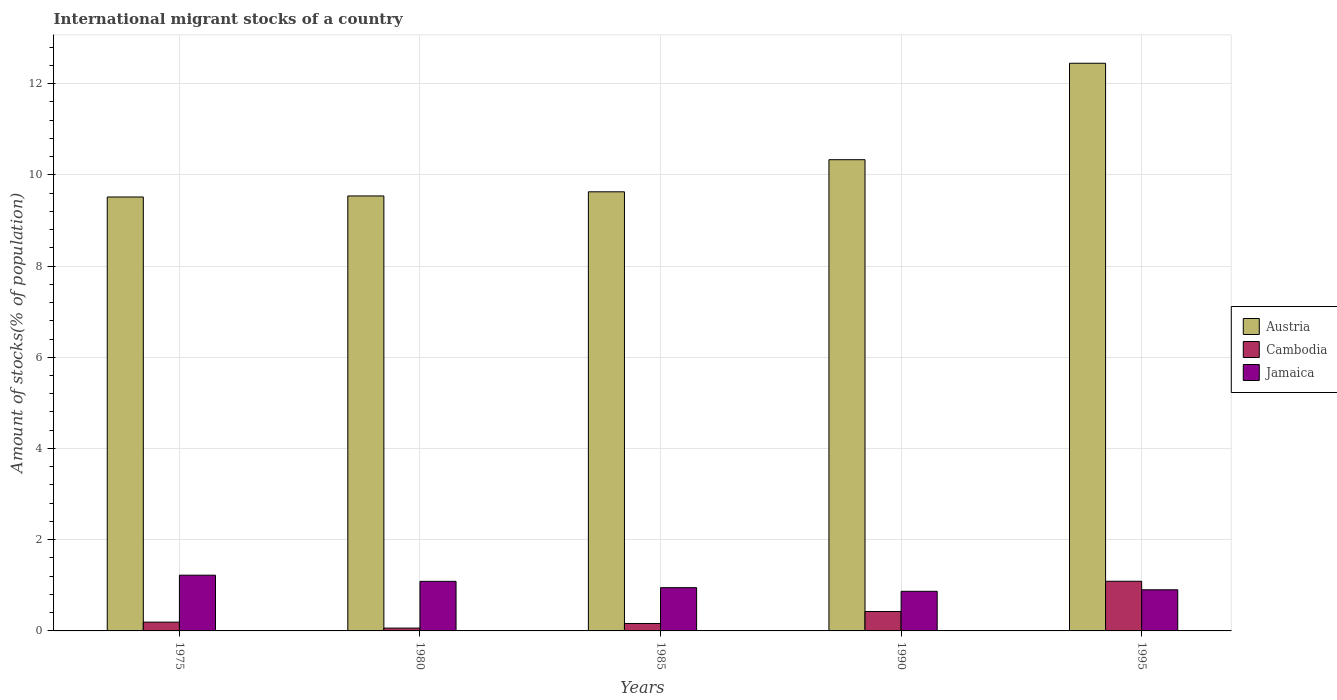What is the label of the 3rd group of bars from the left?
Offer a terse response. 1985. What is the amount of stocks in in Austria in 1985?
Give a very brief answer. 9.63. Across all years, what is the maximum amount of stocks in in Jamaica?
Make the answer very short. 1.22. Across all years, what is the minimum amount of stocks in in Austria?
Make the answer very short. 9.51. What is the total amount of stocks in in Jamaica in the graph?
Offer a terse response. 5.03. What is the difference between the amount of stocks in in Austria in 1975 and that in 1980?
Offer a very short reply. -0.02. What is the difference between the amount of stocks in in Austria in 1995 and the amount of stocks in in Jamaica in 1980?
Ensure brevity in your answer.  11.36. What is the average amount of stocks in in Austria per year?
Give a very brief answer. 10.29. In the year 1975, what is the difference between the amount of stocks in in Austria and amount of stocks in in Jamaica?
Your answer should be very brief. 8.29. In how many years, is the amount of stocks in in Austria greater than 1.6 %?
Offer a very short reply. 5. What is the ratio of the amount of stocks in in Jamaica in 1985 to that in 1990?
Your answer should be compact. 1.09. Is the amount of stocks in in Austria in 1985 less than that in 1990?
Offer a terse response. Yes. What is the difference between the highest and the second highest amount of stocks in in Jamaica?
Provide a succinct answer. 0.14. What is the difference between the highest and the lowest amount of stocks in in Cambodia?
Give a very brief answer. 1.03. In how many years, is the amount of stocks in in Jamaica greater than the average amount of stocks in in Jamaica taken over all years?
Your response must be concise. 2. What does the 2nd bar from the right in 1980 represents?
Your answer should be very brief. Cambodia. Is it the case that in every year, the sum of the amount of stocks in in Cambodia and amount of stocks in in Jamaica is greater than the amount of stocks in in Austria?
Keep it short and to the point. No. How many bars are there?
Offer a very short reply. 15. What is the difference between two consecutive major ticks on the Y-axis?
Ensure brevity in your answer.  2. How many legend labels are there?
Ensure brevity in your answer.  3. How are the legend labels stacked?
Make the answer very short. Vertical. What is the title of the graph?
Your answer should be very brief. International migrant stocks of a country. Does "Belarus" appear as one of the legend labels in the graph?
Make the answer very short. No. What is the label or title of the Y-axis?
Your answer should be compact. Amount of stocks(% of population). What is the Amount of stocks(% of population) in Austria in 1975?
Your response must be concise. 9.51. What is the Amount of stocks(% of population) of Cambodia in 1975?
Give a very brief answer. 0.19. What is the Amount of stocks(% of population) of Jamaica in 1975?
Provide a succinct answer. 1.22. What is the Amount of stocks(% of population) of Austria in 1980?
Your response must be concise. 9.54. What is the Amount of stocks(% of population) of Cambodia in 1980?
Ensure brevity in your answer.  0.06. What is the Amount of stocks(% of population) in Jamaica in 1980?
Offer a very short reply. 1.09. What is the Amount of stocks(% of population) in Austria in 1985?
Your response must be concise. 9.63. What is the Amount of stocks(% of population) of Cambodia in 1985?
Offer a terse response. 0.16. What is the Amount of stocks(% of population) of Jamaica in 1985?
Provide a short and direct response. 0.95. What is the Amount of stocks(% of population) of Austria in 1990?
Provide a succinct answer. 10.33. What is the Amount of stocks(% of population) of Cambodia in 1990?
Offer a very short reply. 0.43. What is the Amount of stocks(% of population) of Jamaica in 1990?
Make the answer very short. 0.87. What is the Amount of stocks(% of population) of Austria in 1995?
Keep it short and to the point. 12.45. What is the Amount of stocks(% of population) of Cambodia in 1995?
Provide a succinct answer. 1.09. What is the Amount of stocks(% of population) in Jamaica in 1995?
Provide a succinct answer. 0.9. Across all years, what is the maximum Amount of stocks(% of population) of Austria?
Provide a short and direct response. 12.45. Across all years, what is the maximum Amount of stocks(% of population) in Cambodia?
Keep it short and to the point. 1.09. Across all years, what is the maximum Amount of stocks(% of population) in Jamaica?
Make the answer very short. 1.22. Across all years, what is the minimum Amount of stocks(% of population) of Austria?
Your answer should be compact. 9.51. Across all years, what is the minimum Amount of stocks(% of population) of Cambodia?
Your answer should be very brief. 0.06. Across all years, what is the minimum Amount of stocks(% of population) in Jamaica?
Your answer should be compact. 0.87. What is the total Amount of stocks(% of population) of Austria in the graph?
Offer a terse response. 51.46. What is the total Amount of stocks(% of population) of Cambodia in the graph?
Your response must be concise. 1.93. What is the total Amount of stocks(% of population) of Jamaica in the graph?
Offer a terse response. 5.03. What is the difference between the Amount of stocks(% of population) of Austria in 1975 and that in 1980?
Your answer should be compact. -0.02. What is the difference between the Amount of stocks(% of population) in Cambodia in 1975 and that in 1980?
Provide a short and direct response. 0.13. What is the difference between the Amount of stocks(% of population) in Jamaica in 1975 and that in 1980?
Give a very brief answer. 0.14. What is the difference between the Amount of stocks(% of population) of Austria in 1975 and that in 1985?
Offer a very short reply. -0.11. What is the difference between the Amount of stocks(% of population) of Cambodia in 1975 and that in 1985?
Ensure brevity in your answer.  0.03. What is the difference between the Amount of stocks(% of population) of Jamaica in 1975 and that in 1985?
Your response must be concise. 0.27. What is the difference between the Amount of stocks(% of population) in Austria in 1975 and that in 1990?
Your answer should be very brief. -0.82. What is the difference between the Amount of stocks(% of population) in Cambodia in 1975 and that in 1990?
Keep it short and to the point. -0.23. What is the difference between the Amount of stocks(% of population) of Jamaica in 1975 and that in 1990?
Offer a very short reply. 0.35. What is the difference between the Amount of stocks(% of population) in Austria in 1975 and that in 1995?
Make the answer very short. -2.93. What is the difference between the Amount of stocks(% of population) of Cambodia in 1975 and that in 1995?
Your response must be concise. -0.9. What is the difference between the Amount of stocks(% of population) of Jamaica in 1975 and that in 1995?
Offer a very short reply. 0.32. What is the difference between the Amount of stocks(% of population) in Austria in 1980 and that in 1985?
Make the answer very short. -0.09. What is the difference between the Amount of stocks(% of population) in Cambodia in 1980 and that in 1985?
Your answer should be compact. -0.1. What is the difference between the Amount of stocks(% of population) of Jamaica in 1980 and that in 1985?
Your answer should be compact. 0.14. What is the difference between the Amount of stocks(% of population) in Austria in 1980 and that in 1990?
Ensure brevity in your answer.  -0.79. What is the difference between the Amount of stocks(% of population) of Cambodia in 1980 and that in 1990?
Make the answer very short. -0.36. What is the difference between the Amount of stocks(% of population) in Jamaica in 1980 and that in 1990?
Give a very brief answer. 0.22. What is the difference between the Amount of stocks(% of population) in Austria in 1980 and that in 1995?
Offer a very short reply. -2.91. What is the difference between the Amount of stocks(% of population) in Cambodia in 1980 and that in 1995?
Offer a very short reply. -1.03. What is the difference between the Amount of stocks(% of population) of Jamaica in 1980 and that in 1995?
Make the answer very short. 0.19. What is the difference between the Amount of stocks(% of population) in Austria in 1985 and that in 1990?
Offer a terse response. -0.7. What is the difference between the Amount of stocks(% of population) of Cambodia in 1985 and that in 1990?
Ensure brevity in your answer.  -0.26. What is the difference between the Amount of stocks(% of population) in Jamaica in 1985 and that in 1990?
Ensure brevity in your answer.  0.08. What is the difference between the Amount of stocks(% of population) in Austria in 1985 and that in 1995?
Your response must be concise. -2.82. What is the difference between the Amount of stocks(% of population) in Cambodia in 1985 and that in 1995?
Provide a succinct answer. -0.93. What is the difference between the Amount of stocks(% of population) of Jamaica in 1985 and that in 1995?
Keep it short and to the point. 0.05. What is the difference between the Amount of stocks(% of population) of Austria in 1990 and that in 1995?
Provide a short and direct response. -2.11. What is the difference between the Amount of stocks(% of population) of Cambodia in 1990 and that in 1995?
Offer a very short reply. -0.66. What is the difference between the Amount of stocks(% of population) of Jamaica in 1990 and that in 1995?
Your answer should be compact. -0.03. What is the difference between the Amount of stocks(% of population) of Austria in 1975 and the Amount of stocks(% of population) of Cambodia in 1980?
Your response must be concise. 9.45. What is the difference between the Amount of stocks(% of population) of Austria in 1975 and the Amount of stocks(% of population) of Jamaica in 1980?
Make the answer very short. 8.43. What is the difference between the Amount of stocks(% of population) in Cambodia in 1975 and the Amount of stocks(% of population) in Jamaica in 1980?
Offer a very short reply. -0.89. What is the difference between the Amount of stocks(% of population) in Austria in 1975 and the Amount of stocks(% of population) in Cambodia in 1985?
Ensure brevity in your answer.  9.35. What is the difference between the Amount of stocks(% of population) of Austria in 1975 and the Amount of stocks(% of population) of Jamaica in 1985?
Offer a very short reply. 8.57. What is the difference between the Amount of stocks(% of population) of Cambodia in 1975 and the Amount of stocks(% of population) of Jamaica in 1985?
Offer a very short reply. -0.76. What is the difference between the Amount of stocks(% of population) in Austria in 1975 and the Amount of stocks(% of population) in Cambodia in 1990?
Offer a terse response. 9.09. What is the difference between the Amount of stocks(% of population) of Austria in 1975 and the Amount of stocks(% of population) of Jamaica in 1990?
Your answer should be very brief. 8.65. What is the difference between the Amount of stocks(% of population) in Cambodia in 1975 and the Amount of stocks(% of population) in Jamaica in 1990?
Provide a short and direct response. -0.68. What is the difference between the Amount of stocks(% of population) of Austria in 1975 and the Amount of stocks(% of population) of Cambodia in 1995?
Ensure brevity in your answer.  8.42. What is the difference between the Amount of stocks(% of population) in Austria in 1975 and the Amount of stocks(% of population) in Jamaica in 1995?
Your response must be concise. 8.61. What is the difference between the Amount of stocks(% of population) of Cambodia in 1975 and the Amount of stocks(% of population) of Jamaica in 1995?
Offer a terse response. -0.71. What is the difference between the Amount of stocks(% of population) in Austria in 1980 and the Amount of stocks(% of population) in Cambodia in 1985?
Provide a succinct answer. 9.37. What is the difference between the Amount of stocks(% of population) of Austria in 1980 and the Amount of stocks(% of population) of Jamaica in 1985?
Your answer should be compact. 8.59. What is the difference between the Amount of stocks(% of population) of Cambodia in 1980 and the Amount of stocks(% of population) of Jamaica in 1985?
Ensure brevity in your answer.  -0.89. What is the difference between the Amount of stocks(% of population) in Austria in 1980 and the Amount of stocks(% of population) in Cambodia in 1990?
Make the answer very short. 9.11. What is the difference between the Amount of stocks(% of population) of Austria in 1980 and the Amount of stocks(% of population) of Jamaica in 1990?
Your answer should be very brief. 8.67. What is the difference between the Amount of stocks(% of population) of Cambodia in 1980 and the Amount of stocks(% of population) of Jamaica in 1990?
Offer a very short reply. -0.81. What is the difference between the Amount of stocks(% of population) of Austria in 1980 and the Amount of stocks(% of population) of Cambodia in 1995?
Your answer should be compact. 8.45. What is the difference between the Amount of stocks(% of population) in Austria in 1980 and the Amount of stocks(% of population) in Jamaica in 1995?
Provide a succinct answer. 8.63. What is the difference between the Amount of stocks(% of population) of Cambodia in 1980 and the Amount of stocks(% of population) of Jamaica in 1995?
Give a very brief answer. -0.84. What is the difference between the Amount of stocks(% of population) in Austria in 1985 and the Amount of stocks(% of population) in Cambodia in 1990?
Offer a very short reply. 9.2. What is the difference between the Amount of stocks(% of population) in Austria in 1985 and the Amount of stocks(% of population) in Jamaica in 1990?
Keep it short and to the point. 8.76. What is the difference between the Amount of stocks(% of population) in Cambodia in 1985 and the Amount of stocks(% of population) in Jamaica in 1990?
Your response must be concise. -0.71. What is the difference between the Amount of stocks(% of population) in Austria in 1985 and the Amount of stocks(% of population) in Cambodia in 1995?
Give a very brief answer. 8.54. What is the difference between the Amount of stocks(% of population) of Austria in 1985 and the Amount of stocks(% of population) of Jamaica in 1995?
Your response must be concise. 8.73. What is the difference between the Amount of stocks(% of population) of Cambodia in 1985 and the Amount of stocks(% of population) of Jamaica in 1995?
Your response must be concise. -0.74. What is the difference between the Amount of stocks(% of population) in Austria in 1990 and the Amount of stocks(% of population) in Cambodia in 1995?
Offer a very short reply. 9.24. What is the difference between the Amount of stocks(% of population) of Austria in 1990 and the Amount of stocks(% of population) of Jamaica in 1995?
Provide a succinct answer. 9.43. What is the difference between the Amount of stocks(% of population) of Cambodia in 1990 and the Amount of stocks(% of population) of Jamaica in 1995?
Provide a short and direct response. -0.48. What is the average Amount of stocks(% of population) of Austria per year?
Your response must be concise. 10.29. What is the average Amount of stocks(% of population) in Cambodia per year?
Offer a very short reply. 0.39. In the year 1975, what is the difference between the Amount of stocks(% of population) in Austria and Amount of stocks(% of population) in Cambodia?
Offer a terse response. 9.32. In the year 1975, what is the difference between the Amount of stocks(% of population) of Austria and Amount of stocks(% of population) of Jamaica?
Ensure brevity in your answer.  8.29. In the year 1975, what is the difference between the Amount of stocks(% of population) in Cambodia and Amount of stocks(% of population) in Jamaica?
Your answer should be very brief. -1.03. In the year 1980, what is the difference between the Amount of stocks(% of population) in Austria and Amount of stocks(% of population) in Cambodia?
Your answer should be very brief. 9.47. In the year 1980, what is the difference between the Amount of stocks(% of population) in Austria and Amount of stocks(% of population) in Jamaica?
Ensure brevity in your answer.  8.45. In the year 1980, what is the difference between the Amount of stocks(% of population) of Cambodia and Amount of stocks(% of population) of Jamaica?
Ensure brevity in your answer.  -1.02. In the year 1985, what is the difference between the Amount of stocks(% of population) in Austria and Amount of stocks(% of population) in Cambodia?
Your answer should be very brief. 9.46. In the year 1985, what is the difference between the Amount of stocks(% of population) of Austria and Amount of stocks(% of population) of Jamaica?
Your answer should be very brief. 8.68. In the year 1985, what is the difference between the Amount of stocks(% of population) of Cambodia and Amount of stocks(% of population) of Jamaica?
Your response must be concise. -0.79. In the year 1990, what is the difference between the Amount of stocks(% of population) of Austria and Amount of stocks(% of population) of Cambodia?
Your response must be concise. 9.91. In the year 1990, what is the difference between the Amount of stocks(% of population) of Austria and Amount of stocks(% of population) of Jamaica?
Provide a succinct answer. 9.46. In the year 1990, what is the difference between the Amount of stocks(% of population) of Cambodia and Amount of stocks(% of population) of Jamaica?
Your answer should be compact. -0.44. In the year 1995, what is the difference between the Amount of stocks(% of population) of Austria and Amount of stocks(% of population) of Cambodia?
Offer a very short reply. 11.36. In the year 1995, what is the difference between the Amount of stocks(% of population) in Austria and Amount of stocks(% of population) in Jamaica?
Keep it short and to the point. 11.54. In the year 1995, what is the difference between the Amount of stocks(% of population) of Cambodia and Amount of stocks(% of population) of Jamaica?
Make the answer very short. 0.19. What is the ratio of the Amount of stocks(% of population) in Austria in 1975 to that in 1980?
Your response must be concise. 1. What is the ratio of the Amount of stocks(% of population) in Cambodia in 1975 to that in 1980?
Your answer should be compact. 3.11. What is the ratio of the Amount of stocks(% of population) of Jamaica in 1975 to that in 1980?
Your response must be concise. 1.12. What is the ratio of the Amount of stocks(% of population) in Cambodia in 1975 to that in 1985?
Offer a very short reply. 1.18. What is the ratio of the Amount of stocks(% of population) in Jamaica in 1975 to that in 1985?
Make the answer very short. 1.29. What is the ratio of the Amount of stocks(% of population) in Austria in 1975 to that in 1990?
Make the answer very short. 0.92. What is the ratio of the Amount of stocks(% of population) of Cambodia in 1975 to that in 1990?
Your answer should be compact. 0.45. What is the ratio of the Amount of stocks(% of population) in Jamaica in 1975 to that in 1990?
Provide a short and direct response. 1.41. What is the ratio of the Amount of stocks(% of population) in Austria in 1975 to that in 1995?
Make the answer very short. 0.76. What is the ratio of the Amount of stocks(% of population) in Cambodia in 1975 to that in 1995?
Provide a succinct answer. 0.18. What is the ratio of the Amount of stocks(% of population) in Jamaica in 1975 to that in 1995?
Your response must be concise. 1.36. What is the ratio of the Amount of stocks(% of population) in Cambodia in 1980 to that in 1985?
Offer a terse response. 0.38. What is the ratio of the Amount of stocks(% of population) of Jamaica in 1980 to that in 1985?
Offer a terse response. 1.15. What is the ratio of the Amount of stocks(% of population) in Austria in 1980 to that in 1990?
Ensure brevity in your answer.  0.92. What is the ratio of the Amount of stocks(% of population) in Cambodia in 1980 to that in 1990?
Offer a terse response. 0.15. What is the ratio of the Amount of stocks(% of population) of Jamaica in 1980 to that in 1990?
Your answer should be very brief. 1.25. What is the ratio of the Amount of stocks(% of population) in Austria in 1980 to that in 1995?
Ensure brevity in your answer.  0.77. What is the ratio of the Amount of stocks(% of population) in Cambodia in 1980 to that in 1995?
Your answer should be compact. 0.06. What is the ratio of the Amount of stocks(% of population) of Jamaica in 1980 to that in 1995?
Your response must be concise. 1.21. What is the ratio of the Amount of stocks(% of population) of Austria in 1985 to that in 1990?
Provide a short and direct response. 0.93. What is the ratio of the Amount of stocks(% of population) in Cambodia in 1985 to that in 1990?
Give a very brief answer. 0.38. What is the ratio of the Amount of stocks(% of population) in Jamaica in 1985 to that in 1990?
Keep it short and to the point. 1.09. What is the ratio of the Amount of stocks(% of population) of Austria in 1985 to that in 1995?
Offer a very short reply. 0.77. What is the ratio of the Amount of stocks(% of population) in Jamaica in 1985 to that in 1995?
Offer a terse response. 1.05. What is the ratio of the Amount of stocks(% of population) in Austria in 1990 to that in 1995?
Provide a short and direct response. 0.83. What is the ratio of the Amount of stocks(% of population) in Cambodia in 1990 to that in 1995?
Offer a terse response. 0.39. What is the ratio of the Amount of stocks(% of population) in Jamaica in 1990 to that in 1995?
Ensure brevity in your answer.  0.96. What is the difference between the highest and the second highest Amount of stocks(% of population) in Austria?
Offer a very short reply. 2.11. What is the difference between the highest and the second highest Amount of stocks(% of population) in Cambodia?
Provide a succinct answer. 0.66. What is the difference between the highest and the second highest Amount of stocks(% of population) in Jamaica?
Give a very brief answer. 0.14. What is the difference between the highest and the lowest Amount of stocks(% of population) of Austria?
Your answer should be very brief. 2.93. What is the difference between the highest and the lowest Amount of stocks(% of population) in Cambodia?
Your answer should be compact. 1.03. What is the difference between the highest and the lowest Amount of stocks(% of population) in Jamaica?
Your answer should be compact. 0.35. 